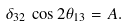<formula> <loc_0><loc_0><loc_500><loc_500>\delta _ { 3 2 } \, \cos 2 \theta _ { 1 3 } = A .</formula> 